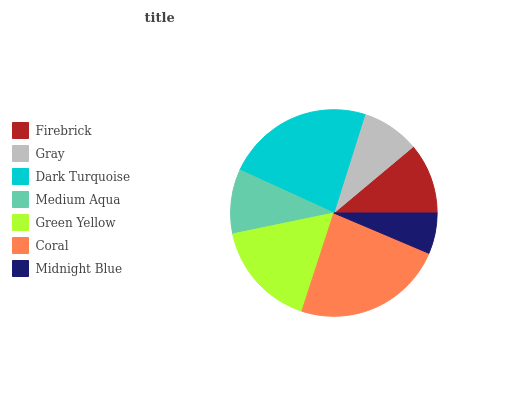Is Midnight Blue the minimum?
Answer yes or no. Yes. Is Coral the maximum?
Answer yes or no. Yes. Is Gray the minimum?
Answer yes or no. No. Is Gray the maximum?
Answer yes or no. No. Is Firebrick greater than Gray?
Answer yes or no. Yes. Is Gray less than Firebrick?
Answer yes or no. Yes. Is Gray greater than Firebrick?
Answer yes or no. No. Is Firebrick less than Gray?
Answer yes or no. No. Is Firebrick the high median?
Answer yes or no. Yes. Is Firebrick the low median?
Answer yes or no. Yes. Is Gray the high median?
Answer yes or no. No. Is Dark Turquoise the low median?
Answer yes or no. No. 